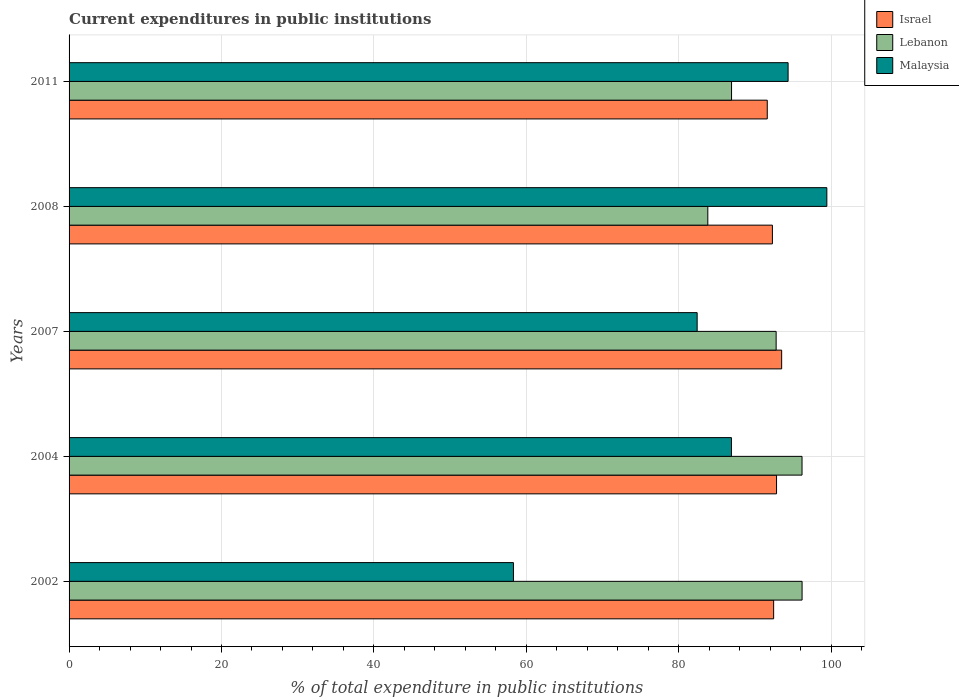How many groups of bars are there?
Make the answer very short. 5. How many bars are there on the 1st tick from the bottom?
Keep it short and to the point. 3. What is the label of the 3rd group of bars from the top?
Provide a short and direct response. 2007. In how many cases, is the number of bars for a given year not equal to the number of legend labels?
Ensure brevity in your answer.  0. What is the current expenditures in public institutions in Malaysia in 2002?
Your answer should be compact. 58.31. Across all years, what is the maximum current expenditures in public institutions in Lebanon?
Give a very brief answer. 96.19. Across all years, what is the minimum current expenditures in public institutions in Lebanon?
Your answer should be compact. 83.82. In which year was the current expenditures in public institutions in Malaysia minimum?
Keep it short and to the point. 2002. What is the total current expenditures in public institutions in Lebanon in the graph?
Your answer should be compact. 455.9. What is the difference between the current expenditures in public institutions in Lebanon in 2004 and that in 2008?
Provide a succinct answer. 12.37. What is the difference between the current expenditures in public institutions in Malaysia in 2004 and the current expenditures in public institutions in Lebanon in 2011?
Offer a terse response. -0.02. What is the average current expenditures in public institutions in Israel per year?
Your response must be concise. 92.54. In the year 2011, what is the difference between the current expenditures in public institutions in Israel and current expenditures in public institutions in Lebanon?
Provide a short and direct response. 4.69. What is the ratio of the current expenditures in public institutions in Malaysia in 2004 to that in 2008?
Make the answer very short. 0.87. What is the difference between the highest and the second highest current expenditures in public institutions in Lebanon?
Give a very brief answer. 0.01. What is the difference between the highest and the lowest current expenditures in public institutions in Malaysia?
Offer a very short reply. 41.12. In how many years, is the current expenditures in public institutions in Israel greater than the average current expenditures in public institutions in Israel taken over all years?
Your answer should be compact. 2. Is the sum of the current expenditures in public institutions in Lebanon in 2008 and 2011 greater than the maximum current expenditures in public institutions in Israel across all years?
Give a very brief answer. Yes. What does the 3rd bar from the top in 2007 represents?
Your response must be concise. Israel. What does the 2nd bar from the bottom in 2008 represents?
Offer a terse response. Lebanon. How many bars are there?
Your answer should be very brief. 15. Are the values on the major ticks of X-axis written in scientific E-notation?
Offer a very short reply. No. Does the graph contain any zero values?
Ensure brevity in your answer.  No. Does the graph contain grids?
Make the answer very short. Yes. Where does the legend appear in the graph?
Provide a short and direct response. Top right. How many legend labels are there?
Provide a succinct answer. 3. What is the title of the graph?
Your answer should be very brief. Current expenditures in public institutions. What is the label or title of the X-axis?
Ensure brevity in your answer.  % of total expenditure in public institutions. What is the label or title of the Y-axis?
Keep it short and to the point. Years. What is the % of total expenditure in public institutions in Israel in 2002?
Your response must be concise. 92.45. What is the % of total expenditure in public institutions of Lebanon in 2002?
Make the answer very short. 96.19. What is the % of total expenditure in public institutions in Malaysia in 2002?
Make the answer very short. 58.31. What is the % of total expenditure in public institutions of Israel in 2004?
Ensure brevity in your answer.  92.84. What is the % of total expenditure in public institutions in Lebanon in 2004?
Make the answer very short. 96.18. What is the % of total expenditure in public institutions of Malaysia in 2004?
Your answer should be compact. 86.92. What is the % of total expenditure in public institutions of Israel in 2007?
Give a very brief answer. 93.51. What is the % of total expenditure in public institutions of Lebanon in 2007?
Offer a very short reply. 92.78. What is the % of total expenditure in public institutions of Malaysia in 2007?
Offer a very short reply. 82.42. What is the % of total expenditure in public institutions of Israel in 2008?
Your answer should be compact. 92.29. What is the % of total expenditure in public institutions in Lebanon in 2008?
Your answer should be very brief. 83.82. What is the % of total expenditure in public institutions of Malaysia in 2008?
Provide a short and direct response. 99.44. What is the % of total expenditure in public institutions of Israel in 2011?
Ensure brevity in your answer.  91.62. What is the % of total expenditure in public institutions in Lebanon in 2011?
Make the answer very short. 86.93. What is the % of total expenditure in public institutions in Malaysia in 2011?
Provide a short and direct response. 94.35. Across all years, what is the maximum % of total expenditure in public institutions in Israel?
Give a very brief answer. 93.51. Across all years, what is the maximum % of total expenditure in public institutions of Lebanon?
Your answer should be compact. 96.19. Across all years, what is the maximum % of total expenditure in public institutions of Malaysia?
Make the answer very short. 99.44. Across all years, what is the minimum % of total expenditure in public institutions of Israel?
Offer a terse response. 91.62. Across all years, what is the minimum % of total expenditure in public institutions of Lebanon?
Keep it short and to the point. 83.82. Across all years, what is the minimum % of total expenditure in public institutions in Malaysia?
Offer a very short reply. 58.31. What is the total % of total expenditure in public institutions of Israel in the graph?
Offer a terse response. 462.71. What is the total % of total expenditure in public institutions in Lebanon in the graph?
Your answer should be compact. 455.9. What is the total % of total expenditure in public institutions of Malaysia in the graph?
Provide a short and direct response. 421.43. What is the difference between the % of total expenditure in public institutions in Israel in 2002 and that in 2004?
Your answer should be compact. -0.38. What is the difference between the % of total expenditure in public institutions of Lebanon in 2002 and that in 2004?
Ensure brevity in your answer.  0.01. What is the difference between the % of total expenditure in public institutions of Malaysia in 2002 and that in 2004?
Your answer should be compact. -28.6. What is the difference between the % of total expenditure in public institutions in Israel in 2002 and that in 2007?
Make the answer very short. -1.05. What is the difference between the % of total expenditure in public institutions in Lebanon in 2002 and that in 2007?
Keep it short and to the point. 3.4. What is the difference between the % of total expenditure in public institutions of Malaysia in 2002 and that in 2007?
Keep it short and to the point. -24.11. What is the difference between the % of total expenditure in public institutions in Israel in 2002 and that in 2008?
Ensure brevity in your answer.  0.16. What is the difference between the % of total expenditure in public institutions in Lebanon in 2002 and that in 2008?
Offer a terse response. 12.37. What is the difference between the % of total expenditure in public institutions in Malaysia in 2002 and that in 2008?
Make the answer very short. -41.12. What is the difference between the % of total expenditure in public institutions of Israel in 2002 and that in 2011?
Your answer should be compact. 0.84. What is the difference between the % of total expenditure in public institutions of Lebanon in 2002 and that in 2011?
Your answer should be compact. 9.25. What is the difference between the % of total expenditure in public institutions of Malaysia in 2002 and that in 2011?
Offer a terse response. -36.04. What is the difference between the % of total expenditure in public institutions of Israel in 2004 and that in 2007?
Provide a succinct answer. -0.67. What is the difference between the % of total expenditure in public institutions of Lebanon in 2004 and that in 2007?
Give a very brief answer. 3.4. What is the difference between the % of total expenditure in public institutions in Malaysia in 2004 and that in 2007?
Offer a very short reply. 4.5. What is the difference between the % of total expenditure in public institutions of Israel in 2004 and that in 2008?
Provide a short and direct response. 0.54. What is the difference between the % of total expenditure in public institutions of Lebanon in 2004 and that in 2008?
Provide a succinct answer. 12.37. What is the difference between the % of total expenditure in public institutions of Malaysia in 2004 and that in 2008?
Offer a terse response. -12.52. What is the difference between the % of total expenditure in public institutions in Israel in 2004 and that in 2011?
Your answer should be compact. 1.22. What is the difference between the % of total expenditure in public institutions of Lebanon in 2004 and that in 2011?
Offer a very short reply. 9.25. What is the difference between the % of total expenditure in public institutions in Malaysia in 2004 and that in 2011?
Keep it short and to the point. -7.44. What is the difference between the % of total expenditure in public institutions of Israel in 2007 and that in 2008?
Your response must be concise. 1.22. What is the difference between the % of total expenditure in public institutions of Lebanon in 2007 and that in 2008?
Keep it short and to the point. 8.97. What is the difference between the % of total expenditure in public institutions of Malaysia in 2007 and that in 2008?
Your response must be concise. -17.02. What is the difference between the % of total expenditure in public institutions of Israel in 2007 and that in 2011?
Offer a very short reply. 1.89. What is the difference between the % of total expenditure in public institutions in Lebanon in 2007 and that in 2011?
Offer a very short reply. 5.85. What is the difference between the % of total expenditure in public institutions of Malaysia in 2007 and that in 2011?
Keep it short and to the point. -11.93. What is the difference between the % of total expenditure in public institutions in Israel in 2008 and that in 2011?
Your answer should be very brief. 0.67. What is the difference between the % of total expenditure in public institutions of Lebanon in 2008 and that in 2011?
Offer a very short reply. -3.12. What is the difference between the % of total expenditure in public institutions of Malaysia in 2008 and that in 2011?
Make the answer very short. 5.08. What is the difference between the % of total expenditure in public institutions in Israel in 2002 and the % of total expenditure in public institutions in Lebanon in 2004?
Make the answer very short. -3.73. What is the difference between the % of total expenditure in public institutions in Israel in 2002 and the % of total expenditure in public institutions in Malaysia in 2004?
Your answer should be compact. 5.54. What is the difference between the % of total expenditure in public institutions in Lebanon in 2002 and the % of total expenditure in public institutions in Malaysia in 2004?
Give a very brief answer. 9.27. What is the difference between the % of total expenditure in public institutions in Israel in 2002 and the % of total expenditure in public institutions in Lebanon in 2007?
Your answer should be compact. -0.33. What is the difference between the % of total expenditure in public institutions of Israel in 2002 and the % of total expenditure in public institutions of Malaysia in 2007?
Ensure brevity in your answer.  10.04. What is the difference between the % of total expenditure in public institutions in Lebanon in 2002 and the % of total expenditure in public institutions in Malaysia in 2007?
Offer a terse response. 13.77. What is the difference between the % of total expenditure in public institutions of Israel in 2002 and the % of total expenditure in public institutions of Lebanon in 2008?
Offer a terse response. 8.64. What is the difference between the % of total expenditure in public institutions of Israel in 2002 and the % of total expenditure in public institutions of Malaysia in 2008?
Offer a very short reply. -6.98. What is the difference between the % of total expenditure in public institutions in Lebanon in 2002 and the % of total expenditure in public institutions in Malaysia in 2008?
Provide a succinct answer. -3.25. What is the difference between the % of total expenditure in public institutions of Israel in 2002 and the % of total expenditure in public institutions of Lebanon in 2011?
Offer a very short reply. 5.52. What is the difference between the % of total expenditure in public institutions of Israel in 2002 and the % of total expenditure in public institutions of Malaysia in 2011?
Provide a short and direct response. -1.9. What is the difference between the % of total expenditure in public institutions of Lebanon in 2002 and the % of total expenditure in public institutions of Malaysia in 2011?
Your answer should be very brief. 1.83. What is the difference between the % of total expenditure in public institutions of Israel in 2004 and the % of total expenditure in public institutions of Lebanon in 2007?
Your answer should be compact. 0.05. What is the difference between the % of total expenditure in public institutions in Israel in 2004 and the % of total expenditure in public institutions in Malaysia in 2007?
Your answer should be compact. 10.42. What is the difference between the % of total expenditure in public institutions in Lebanon in 2004 and the % of total expenditure in public institutions in Malaysia in 2007?
Your answer should be compact. 13.76. What is the difference between the % of total expenditure in public institutions of Israel in 2004 and the % of total expenditure in public institutions of Lebanon in 2008?
Your answer should be very brief. 9.02. What is the difference between the % of total expenditure in public institutions of Israel in 2004 and the % of total expenditure in public institutions of Malaysia in 2008?
Provide a short and direct response. -6.6. What is the difference between the % of total expenditure in public institutions of Lebanon in 2004 and the % of total expenditure in public institutions of Malaysia in 2008?
Your response must be concise. -3.25. What is the difference between the % of total expenditure in public institutions in Israel in 2004 and the % of total expenditure in public institutions in Lebanon in 2011?
Your response must be concise. 5.9. What is the difference between the % of total expenditure in public institutions in Israel in 2004 and the % of total expenditure in public institutions in Malaysia in 2011?
Give a very brief answer. -1.52. What is the difference between the % of total expenditure in public institutions in Lebanon in 2004 and the % of total expenditure in public institutions in Malaysia in 2011?
Keep it short and to the point. 1.83. What is the difference between the % of total expenditure in public institutions in Israel in 2007 and the % of total expenditure in public institutions in Lebanon in 2008?
Provide a short and direct response. 9.69. What is the difference between the % of total expenditure in public institutions in Israel in 2007 and the % of total expenditure in public institutions in Malaysia in 2008?
Your response must be concise. -5.93. What is the difference between the % of total expenditure in public institutions in Lebanon in 2007 and the % of total expenditure in public institutions in Malaysia in 2008?
Give a very brief answer. -6.65. What is the difference between the % of total expenditure in public institutions of Israel in 2007 and the % of total expenditure in public institutions of Lebanon in 2011?
Offer a terse response. 6.58. What is the difference between the % of total expenditure in public institutions of Israel in 2007 and the % of total expenditure in public institutions of Malaysia in 2011?
Your response must be concise. -0.84. What is the difference between the % of total expenditure in public institutions in Lebanon in 2007 and the % of total expenditure in public institutions in Malaysia in 2011?
Give a very brief answer. -1.57. What is the difference between the % of total expenditure in public institutions in Israel in 2008 and the % of total expenditure in public institutions in Lebanon in 2011?
Your response must be concise. 5.36. What is the difference between the % of total expenditure in public institutions of Israel in 2008 and the % of total expenditure in public institutions of Malaysia in 2011?
Your answer should be compact. -2.06. What is the difference between the % of total expenditure in public institutions of Lebanon in 2008 and the % of total expenditure in public institutions of Malaysia in 2011?
Offer a terse response. -10.54. What is the average % of total expenditure in public institutions in Israel per year?
Offer a very short reply. 92.54. What is the average % of total expenditure in public institutions of Lebanon per year?
Ensure brevity in your answer.  91.18. What is the average % of total expenditure in public institutions in Malaysia per year?
Give a very brief answer. 84.29. In the year 2002, what is the difference between the % of total expenditure in public institutions of Israel and % of total expenditure in public institutions of Lebanon?
Your response must be concise. -3.73. In the year 2002, what is the difference between the % of total expenditure in public institutions of Israel and % of total expenditure in public institutions of Malaysia?
Ensure brevity in your answer.  34.14. In the year 2002, what is the difference between the % of total expenditure in public institutions of Lebanon and % of total expenditure in public institutions of Malaysia?
Provide a short and direct response. 37.87. In the year 2004, what is the difference between the % of total expenditure in public institutions in Israel and % of total expenditure in public institutions in Lebanon?
Offer a very short reply. -3.35. In the year 2004, what is the difference between the % of total expenditure in public institutions in Israel and % of total expenditure in public institutions in Malaysia?
Your answer should be very brief. 5.92. In the year 2004, what is the difference between the % of total expenditure in public institutions of Lebanon and % of total expenditure in public institutions of Malaysia?
Keep it short and to the point. 9.26. In the year 2007, what is the difference between the % of total expenditure in public institutions in Israel and % of total expenditure in public institutions in Lebanon?
Provide a short and direct response. 0.73. In the year 2007, what is the difference between the % of total expenditure in public institutions of Israel and % of total expenditure in public institutions of Malaysia?
Your answer should be very brief. 11.09. In the year 2007, what is the difference between the % of total expenditure in public institutions in Lebanon and % of total expenditure in public institutions in Malaysia?
Provide a succinct answer. 10.36. In the year 2008, what is the difference between the % of total expenditure in public institutions of Israel and % of total expenditure in public institutions of Lebanon?
Your answer should be compact. 8.48. In the year 2008, what is the difference between the % of total expenditure in public institutions in Israel and % of total expenditure in public institutions in Malaysia?
Make the answer very short. -7.14. In the year 2008, what is the difference between the % of total expenditure in public institutions in Lebanon and % of total expenditure in public institutions in Malaysia?
Offer a very short reply. -15.62. In the year 2011, what is the difference between the % of total expenditure in public institutions of Israel and % of total expenditure in public institutions of Lebanon?
Provide a succinct answer. 4.69. In the year 2011, what is the difference between the % of total expenditure in public institutions in Israel and % of total expenditure in public institutions in Malaysia?
Make the answer very short. -2.73. In the year 2011, what is the difference between the % of total expenditure in public institutions in Lebanon and % of total expenditure in public institutions in Malaysia?
Provide a short and direct response. -7.42. What is the ratio of the % of total expenditure in public institutions of Malaysia in 2002 to that in 2004?
Keep it short and to the point. 0.67. What is the ratio of the % of total expenditure in public institutions in Israel in 2002 to that in 2007?
Offer a terse response. 0.99. What is the ratio of the % of total expenditure in public institutions in Lebanon in 2002 to that in 2007?
Give a very brief answer. 1.04. What is the ratio of the % of total expenditure in public institutions of Malaysia in 2002 to that in 2007?
Your answer should be compact. 0.71. What is the ratio of the % of total expenditure in public institutions in Israel in 2002 to that in 2008?
Keep it short and to the point. 1. What is the ratio of the % of total expenditure in public institutions of Lebanon in 2002 to that in 2008?
Your answer should be compact. 1.15. What is the ratio of the % of total expenditure in public institutions of Malaysia in 2002 to that in 2008?
Your response must be concise. 0.59. What is the ratio of the % of total expenditure in public institutions of Israel in 2002 to that in 2011?
Ensure brevity in your answer.  1.01. What is the ratio of the % of total expenditure in public institutions in Lebanon in 2002 to that in 2011?
Your answer should be compact. 1.11. What is the ratio of the % of total expenditure in public institutions in Malaysia in 2002 to that in 2011?
Offer a very short reply. 0.62. What is the ratio of the % of total expenditure in public institutions of Lebanon in 2004 to that in 2007?
Your answer should be compact. 1.04. What is the ratio of the % of total expenditure in public institutions in Malaysia in 2004 to that in 2007?
Provide a short and direct response. 1.05. What is the ratio of the % of total expenditure in public institutions in Israel in 2004 to that in 2008?
Offer a terse response. 1.01. What is the ratio of the % of total expenditure in public institutions of Lebanon in 2004 to that in 2008?
Keep it short and to the point. 1.15. What is the ratio of the % of total expenditure in public institutions of Malaysia in 2004 to that in 2008?
Make the answer very short. 0.87. What is the ratio of the % of total expenditure in public institutions of Israel in 2004 to that in 2011?
Your answer should be compact. 1.01. What is the ratio of the % of total expenditure in public institutions in Lebanon in 2004 to that in 2011?
Your answer should be very brief. 1.11. What is the ratio of the % of total expenditure in public institutions in Malaysia in 2004 to that in 2011?
Your answer should be very brief. 0.92. What is the ratio of the % of total expenditure in public institutions of Israel in 2007 to that in 2008?
Your answer should be very brief. 1.01. What is the ratio of the % of total expenditure in public institutions in Lebanon in 2007 to that in 2008?
Keep it short and to the point. 1.11. What is the ratio of the % of total expenditure in public institutions in Malaysia in 2007 to that in 2008?
Make the answer very short. 0.83. What is the ratio of the % of total expenditure in public institutions in Israel in 2007 to that in 2011?
Your answer should be compact. 1.02. What is the ratio of the % of total expenditure in public institutions of Lebanon in 2007 to that in 2011?
Provide a succinct answer. 1.07. What is the ratio of the % of total expenditure in public institutions in Malaysia in 2007 to that in 2011?
Keep it short and to the point. 0.87. What is the ratio of the % of total expenditure in public institutions of Israel in 2008 to that in 2011?
Provide a short and direct response. 1.01. What is the ratio of the % of total expenditure in public institutions of Lebanon in 2008 to that in 2011?
Your response must be concise. 0.96. What is the ratio of the % of total expenditure in public institutions in Malaysia in 2008 to that in 2011?
Your answer should be very brief. 1.05. What is the difference between the highest and the second highest % of total expenditure in public institutions in Israel?
Ensure brevity in your answer.  0.67. What is the difference between the highest and the second highest % of total expenditure in public institutions in Lebanon?
Provide a short and direct response. 0.01. What is the difference between the highest and the second highest % of total expenditure in public institutions in Malaysia?
Your response must be concise. 5.08. What is the difference between the highest and the lowest % of total expenditure in public institutions of Israel?
Ensure brevity in your answer.  1.89. What is the difference between the highest and the lowest % of total expenditure in public institutions in Lebanon?
Provide a short and direct response. 12.37. What is the difference between the highest and the lowest % of total expenditure in public institutions in Malaysia?
Keep it short and to the point. 41.12. 